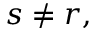<formula> <loc_0><loc_0><loc_500><loc_500>s \neq r ,</formula> 